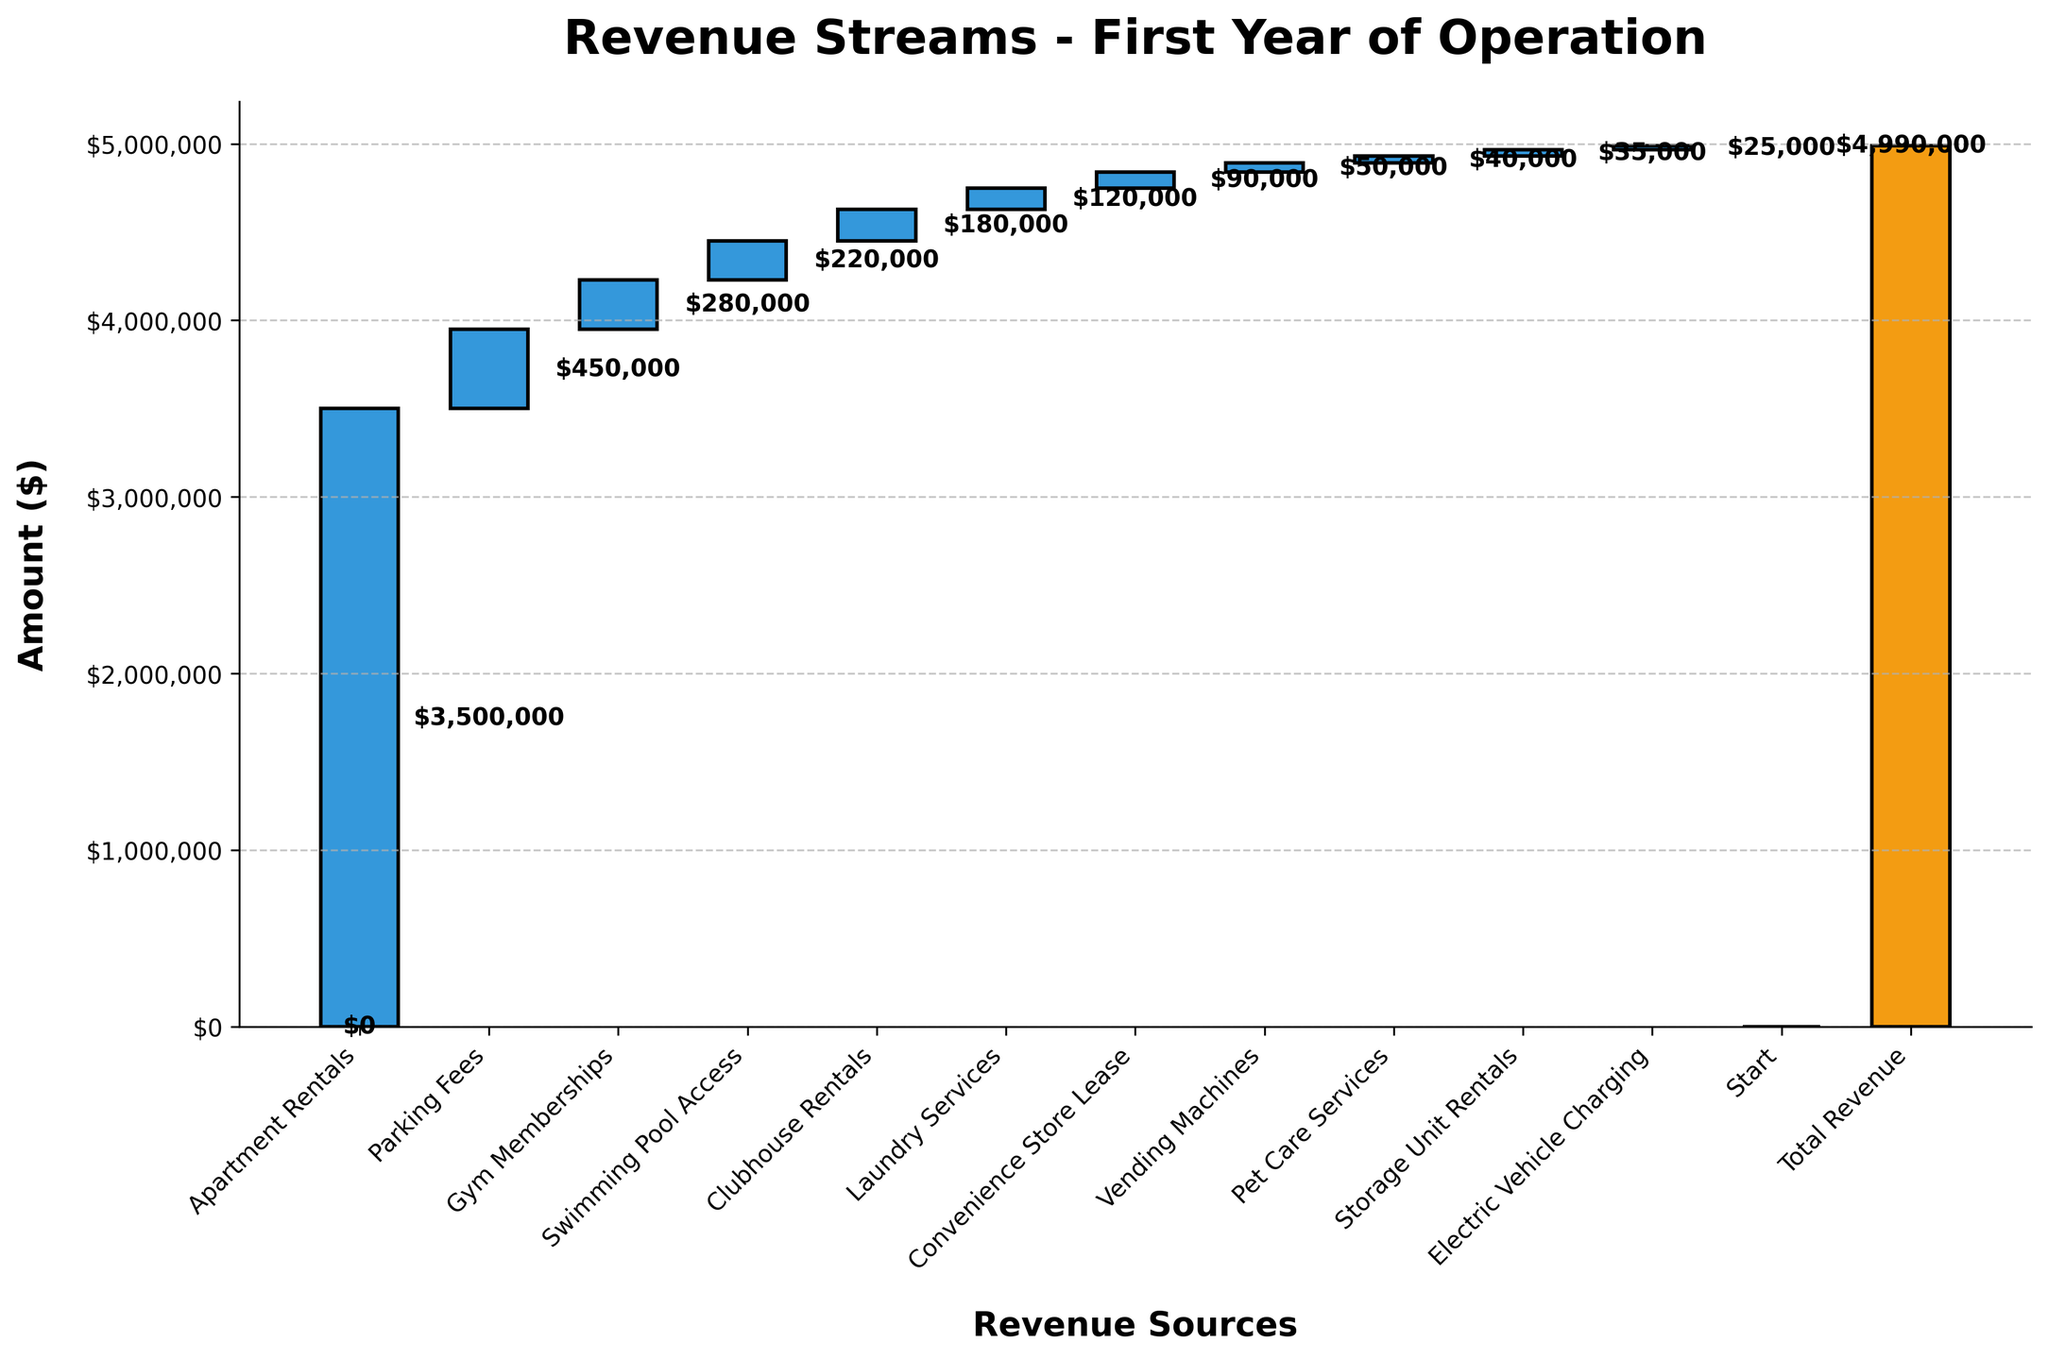what is the title of the chart? The title of the chart is displayed at the very top and center of the figure. Typically, it gives a brief summary of what the chart represents.
Answer: Revenue Streams - First Year of Operation How much revenue is generated from Gym Memberships? The bar labeled "Gym Memberships" gives the revenue specific to this category. The exact amount is also mentioned on the bar itself.
Answer: $280,000 Which revenue source contributed the most? By comparing the heights of the bars, the "Apartment Rentals" have the highest bar, indicating they contributed the most revenue. The text on the bar also shows the exact amount.
Answer: Apartment Rentals What is the color used for the revenue streams? The bars representing positive revenue streams such as "Apartment Rentals" are colored in a blueish tone.
Answer: Blueish tone What was the total revenue at the end of the first year? The last bar labeled "Total Revenue" represents the sum of all revenue sources. The amount shown on this bar is the total revenue.
Answer: $4,990,000 How much more revenue was generated from Parking Fees compared to Electric Vehicle Charging? Determine the amounts for both categories from the respective bars. Subtract Electric Vehicle Charging from Parking Fees. $450,000 (Parking Fees) - $25,000 (Electric Vehicle Charging) = $425,000
Answer: $425,000 What are the revenues generated from Clubhouse Rentals and Convenience Store Lease combined? Add the amounts for both "Clubhouse Rentals" and "Convenience Store Lease" together. $180,000 + $90,000
Answer: $270,000 What is the median value of the revenue streams (excluding Start and Total Revenue)? List all the revenue values excluding "Start" and "Total Revenue", sort them, and find the middle number. Sorted values: 25,000, 35,000, 40,000, 50,000, 90,000, 120,000, 180,000, 220,000, 280,000, 450,000, 3,500,000. Median is 120,000
Answer: $120,000 What is the difference between the revenues generated from Vending Machines and Pet Care Services? Subtract the revenue from Pet Care Services from that of Vending Machines. $50,000 (Vending Machines) - $40,000 (Pet Care Services) = $10,000
Answer: $10,000 How much revenue was generated from all service-based amenities (Gym Memberships, Swimming Pool Access, Clubhouse Rentals, Laundry Services, Pet Care Services) combined? Sum the amounts from the service-based amenities listed. $280,000 + $220,000 + $180,000 + $120,000 + $40,000 = $840,000
Answer: $840,000 